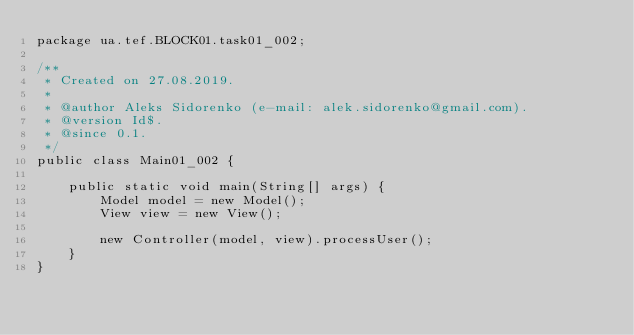Convert code to text. <code><loc_0><loc_0><loc_500><loc_500><_Java_>package ua.tef.BLOCK01.task01_002;

/**
 * Created on 27.08.2019.
 *
 * @author Aleks Sidorenko (e-mail: alek.sidorenko@gmail.com).
 * @version Id$.
 * @since 0.1.
 */
public class Main01_002 {

    public static void main(String[] args) {
        Model model = new Model();
        View view = new View();

        new Controller(model, view).processUser();
    }
}
</code> 